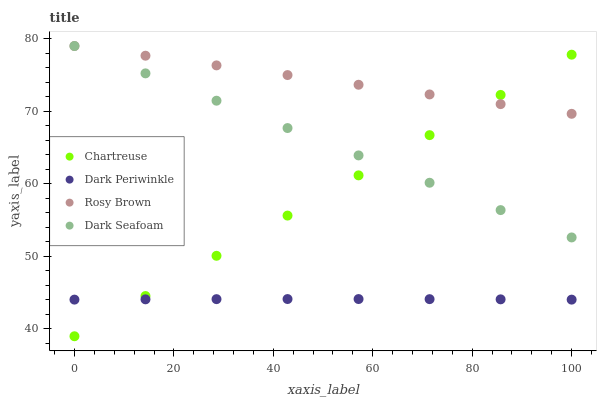Does Dark Periwinkle have the minimum area under the curve?
Answer yes or no. Yes. Does Rosy Brown have the maximum area under the curve?
Answer yes or no. Yes. Does Rosy Brown have the minimum area under the curve?
Answer yes or no. No. Does Dark Periwinkle have the maximum area under the curve?
Answer yes or no. No. Is Chartreuse the smoothest?
Answer yes or no. Yes. Is Dark Periwinkle the roughest?
Answer yes or no. Yes. Is Rosy Brown the smoothest?
Answer yes or no. No. Is Rosy Brown the roughest?
Answer yes or no. No. Does Chartreuse have the lowest value?
Answer yes or no. Yes. Does Dark Periwinkle have the lowest value?
Answer yes or no. No. Does Dark Seafoam have the highest value?
Answer yes or no. Yes. Does Dark Periwinkle have the highest value?
Answer yes or no. No. Is Dark Periwinkle less than Dark Seafoam?
Answer yes or no. Yes. Is Dark Seafoam greater than Dark Periwinkle?
Answer yes or no. Yes. Does Rosy Brown intersect Dark Seafoam?
Answer yes or no. Yes. Is Rosy Brown less than Dark Seafoam?
Answer yes or no. No. Is Rosy Brown greater than Dark Seafoam?
Answer yes or no. No. Does Dark Periwinkle intersect Dark Seafoam?
Answer yes or no. No. 